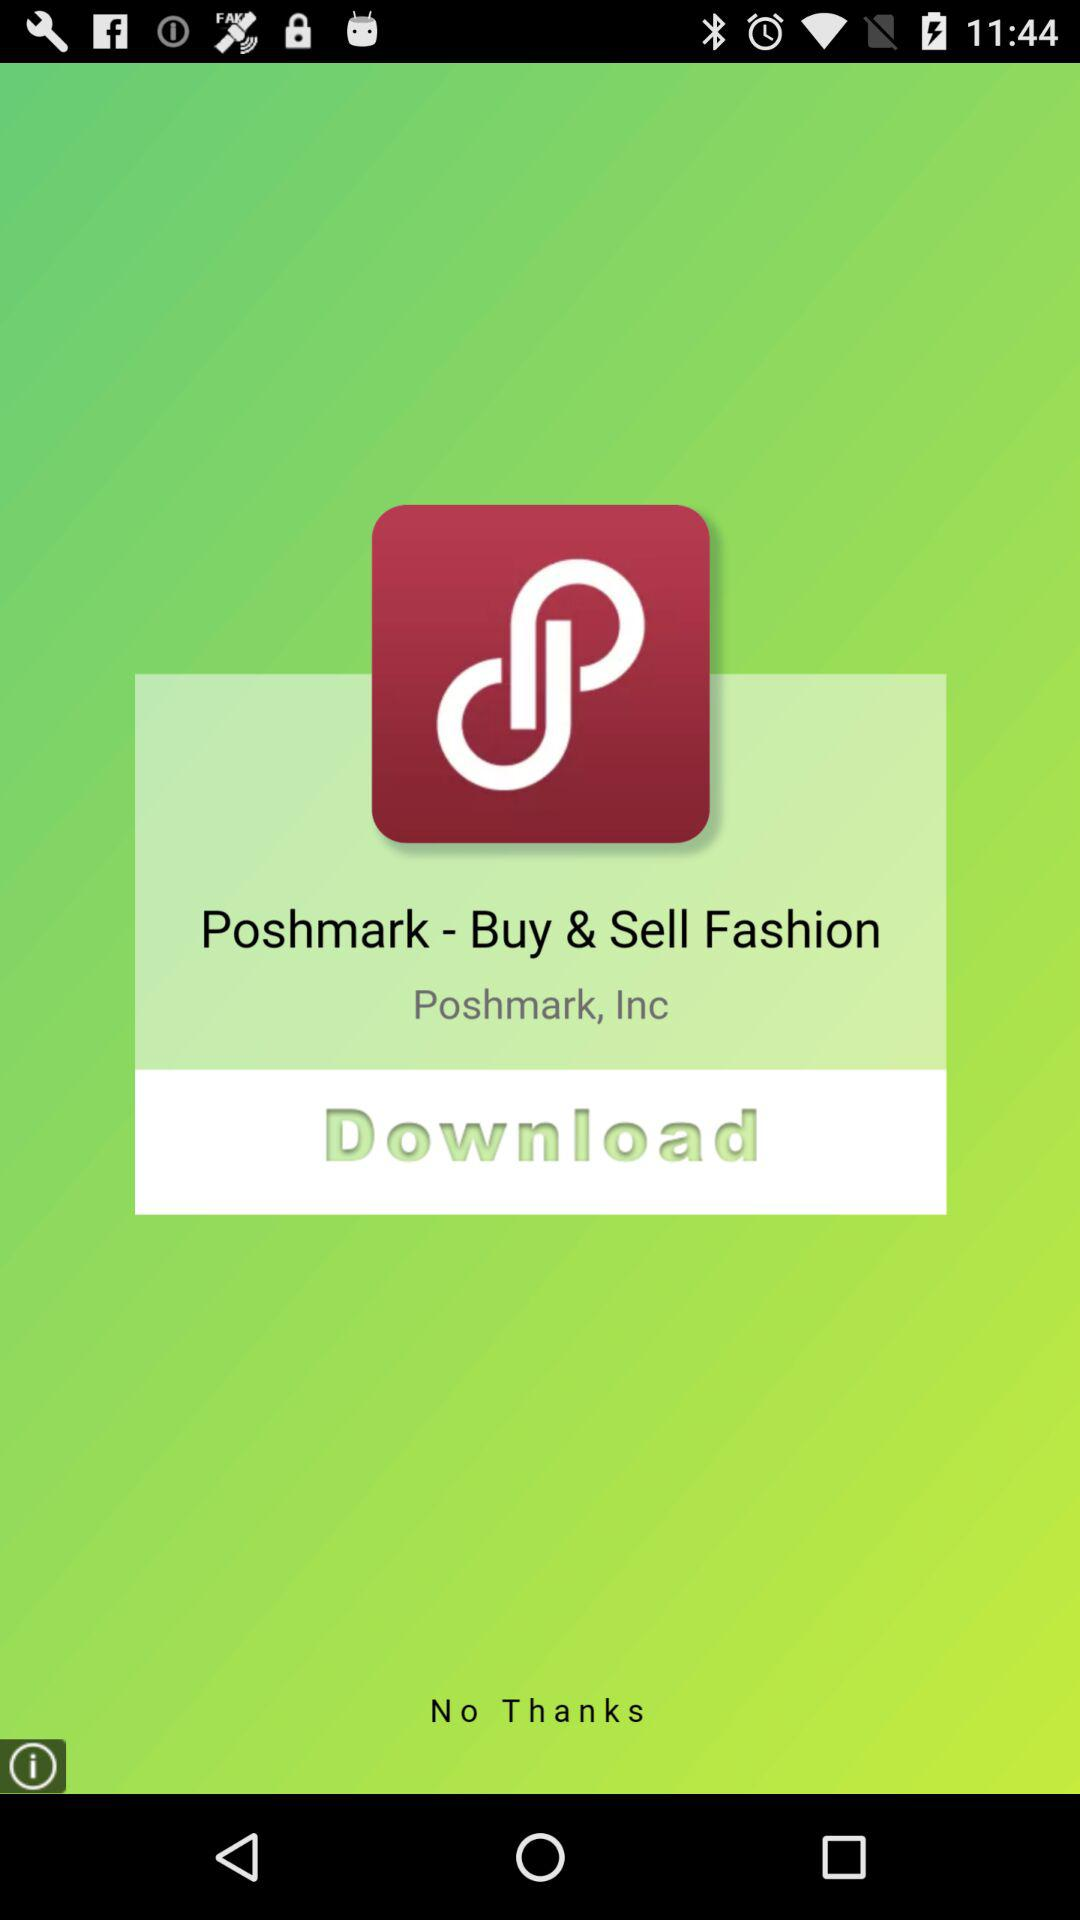How many people have downloaded "Poshmark - Buy & Sell Fashion"?
When the provided information is insufficient, respond with <no answer>. <no answer> 